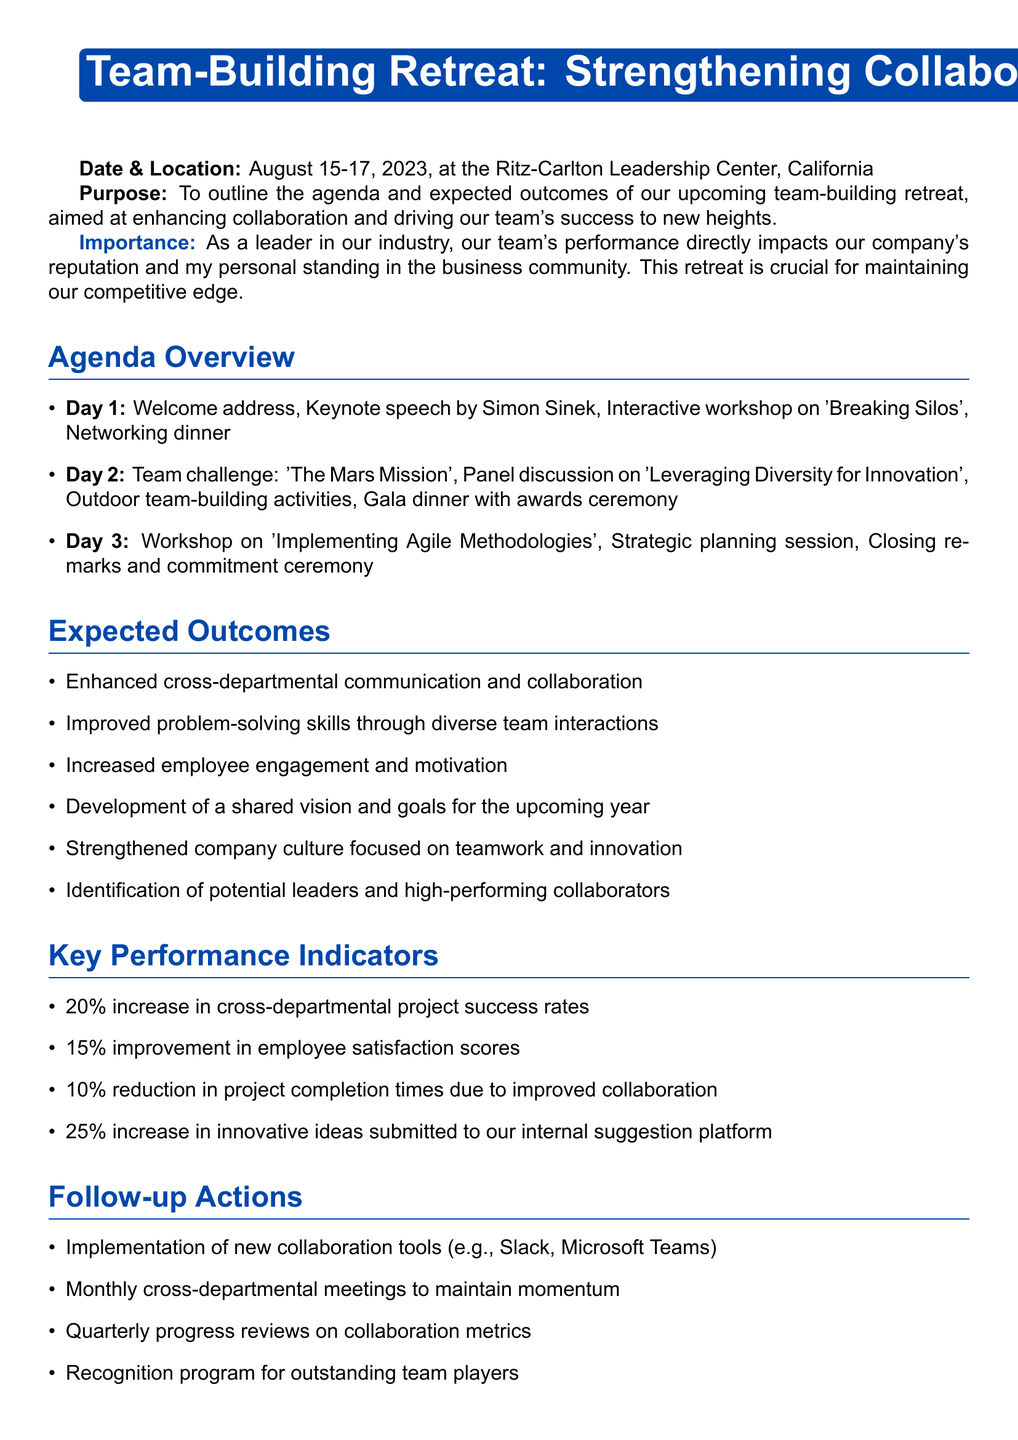What are the dates of the retreat? The dates for the retreat are specified in the introduction section: August 15-17, 2023.
Answer: August 15-17, 2023 Who is the keynote speaker for Day 1? The document states that the keynote speech is by Simon Sinek on Day 1.
Answer: Simon Sinek What is the first activity scheduled for Day 2? The agenda indicates the first activity on Day 2 is the team challenge: 'The Mars Mission'.
Answer: 'The Mars Mission' What is one expected outcome of the retreat? The section on expected outcomes lists several, including the enhancement of cross-departmental communication.
Answer: Enhanced cross-departmental communication and collaboration What is the target improvement in employee satisfaction scores? The key performance indicators mention a specific improvement target of 15% in employee satisfaction scores.
Answer: 15% What tool is mentioned for implementation after the retreat? The follow-up actions section includes the implementation of collaboration tools such as Slack.
Answer: Slack What type of award will occur during the gala dinner? The agenda specifies that there will be an awards ceremony recognizing top collaborators at the gala dinner.
Answer: Awards ceremony recognizing top collaborators How many days does the retreat last? The introduction states that the retreat lasts for three days.
Answer: Three days What overarching goal does the final vision statement emphasize? The vision statement emphasizes setting the stage for industry-leading performance that will elevate the company's status.
Answer: Elevate our company's status 